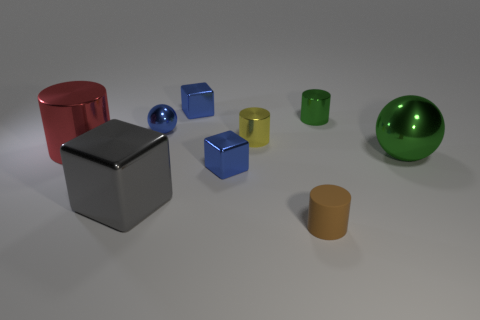Subtract all blue cubes. How many were subtracted if there are1blue cubes left? 1 Subtract all small blue cubes. How many cubes are left? 1 Subtract all green cylinders. How many cylinders are left? 3 Add 9 big green metal balls. How many big green metal balls are left? 10 Add 4 tiny metal things. How many tiny metal things exist? 9 Subtract 1 yellow cylinders. How many objects are left? 8 Subtract all spheres. How many objects are left? 7 Subtract 1 cubes. How many cubes are left? 2 Subtract all yellow cubes. Subtract all yellow balls. How many cubes are left? 3 Subtract all gray spheres. How many green cylinders are left? 1 